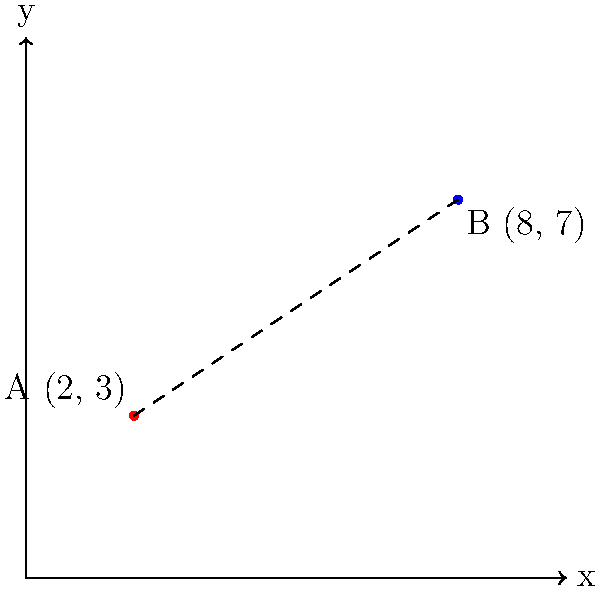In a paratriathlon race, two transition points A and B are marked on a 2D map using Cartesian coordinates. Point A (swim-to-bike transition) is located at (2, 3), and point B (bike-to-run transition) is at (8, 7). Calculate the straight-line distance between these two transition points to the nearest tenth of a unit. To find the straight-line distance between two points in a 2D Cartesian coordinate system, we can use the distance formula, which is derived from the Pythagorean theorem:

$$ d = \sqrt{(x_2 - x_1)^2 + (y_2 - y_1)^2} $$

Where $(x_1, y_1)$ are the coordinates of the first point and $(x_2, y_2)$ are the coordinates of the second point.

Step 1: Identify the coordinates
Point A: $(x_1, y_1) = (2, 3)$
Point B: $(x_2, y_2) = (8, 7)$

Step 2: Plug the coordinates into the distance formula
$$ d = \sqrt{(8 - 2)^2 + (7 - 3)^2} $$

Step 3: Simplify the expressions inside the parentheses
$$ d = \sqrt{6^2 + 4^2} $$

Step 4: Calculate the squares
$$ d = \sqrt{36 + 16} $$

Step 5: Add the values under the square root
$$ d = \sqrt{52} $$

Step 6: Calculate the square root and round to the nearest tenth
$$ d \approx 7.2 $$

Therefore, the straight-line distance between the two transition points is approximately 7.2 units.
Answer: 7.2 units 